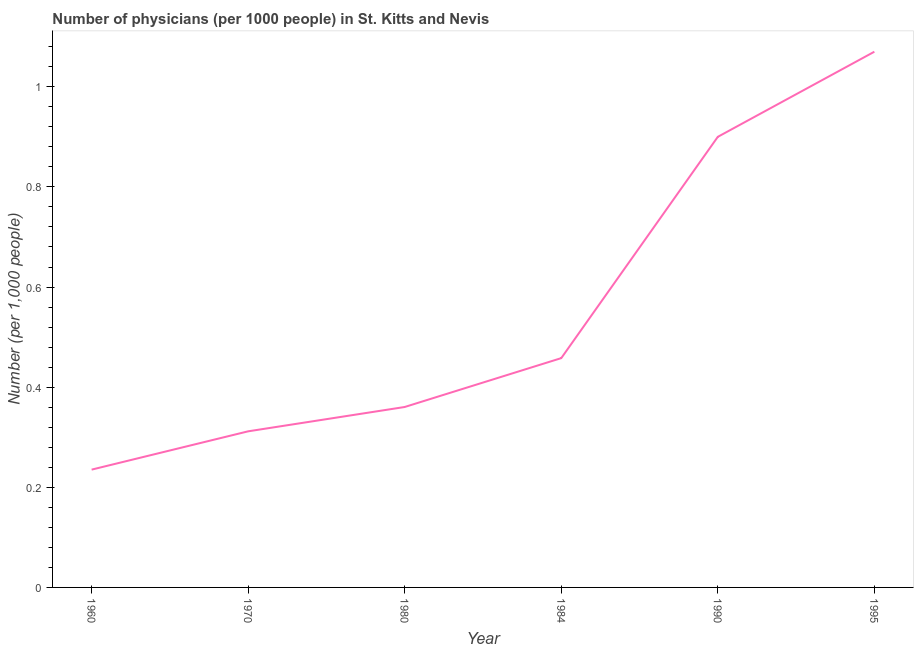What is the number of physicians in 1970?
Offer a terse response. 0.31. Across all years, what is the maximum number of physicians?
Provide a succinct answer. 1.07. Across all years, what is the minimum number of physicians?
Give a very brief answer. 0.24. In which year was the number of physicians maximum?
Your response must be concise. 1995. What is the sum of the number of physicians?
Your response must be concise. 3.34. What is the difference between the number of physicians in 1980 and 1995?
Your answer should be very brief. -0.71. What is the average number of physicians per year?
Provide a short and direct response. 0.56. What is the median number of physicians?
Provide a short and direct response. 0.41. What is the ratio of the number of physicians in 1980 to that in 1990?
Offer a very short reply. 0.4. What is the difference between the highest and the second highest number of physicians?
Keep it short and to the point. 0.17. Is the sum of the number of physicians in 1980 and 1995 greater than the maximum number of physicians across all years?
Keep it short and to the point. Yes. What is the difference between the highest and the lowest number of physicians?
Keep it short and to the point. 0.83. How many years are there in the graph?
Ensure brevity in your answer.  6. Are the values on the major ticks of Y-axis written in scientific E-notation?
Keep it short and to the point. No. Does the graph contain grids?
Provide a succinct answer. No. What is the title of the graph?
Your response must be concise. Number of physicians (per 1000 people) in St. Kitts and Nevis. What is the label or title of the X-axis?
Your answer should be very brief. Year. What is the label or title of the Y-axis?
Provide a succinct answer. Number (per 1,0 people). What is the Number (per 1,000 people) in 1960?
Offer a very short reply. 0.24. What is the Number (per 1,000 people) of 1970?
Your response must be concise. 0.31. What is the Number (per 1,000 people) of 1980?
Provide a short and direct response. 0.36. What is the Number (per 1,000 people) in 1984?
Keep it short and to the point. 0.46. What is the Number (per 1,000 people) of 1990?
Your answer should be very brief. 0.9. What is the Number (per 1,000 people) of 1995?
Make the answer very short. 1.07. What is the difference between the Number (per 1,000 people) in 1960 and 1970?
Your answer should be compact. -0.08. What is the difference between the Number (per 1,000 people) in 1960 and 1980?
Offer a terse response. -0.13. What is the difference between the Number (per 1,000 people) in 1960 and 1984?
Ensure brevity in your answer.  -0.22. What is the difference between the Number (per 1,000 people) in 1960 and 1990?
Your answer should be compact. -0.66. What is the difference between the Number (per 1,000 people) in 1960 and 1995?
Keep it short and to the point. -0.83. What is the difference between the Number (per 1,000 people) in 1970 and 1980?
Make the answer very short. -0.05. What is the difference between the Number (per 1,000 people) in 1970 and 1984?
Give a very brief answer. -0.15. What is the difference between the Number (per 1,000 people) in 1970 and 1990?
Offer a terse response. -0.59. What is the difference between the Number (per 1,000 people) in 1970 and 1995?
Offer a terse response. -0.76. What is the difference between the Number (per 1,000 people) in 1980 and 1984?
Offer a terse response. -0.1. What is the difference between the Number (per 1,000 people) in 1980 and 1990?
Your response must be concise. -0.54. What is the difference between the Number (per 1,000 people) in 1980 and 1995?
Offer a terse response. -0.71. What is the difference between the Number (per 1,000 people) in 1984 and 1990?
Ensure brevity in your answer.  -0.44. What is the difference between the Number (per 1,000 people) in 1984 and 1995?
Ensure brevity in your answer.  -0.61. What is the difference between the Number (per 1,000 people) in 1990 and 1995?
Give a very brief answer. -0.17. What is the ratio of the Number (per 1,000 people) in 1960 to that in 1970?
Offer a very short reply. 0.76. What is the ratio of the Number (per 1,000 people) in 1960 to that in 1980?
Your answer should be very brief. 0.65. What is the ratio of the Number (per 1,000 people) in 1960 to that in 1984?
Keep it short and to the point. 0.51. What is the ratio of the Number (per 1,000 people) in 1960 to that in 1990?
Offer a very short reply. 0.26. What is the ratio of the Number (per 1,000 people) in 1960 to that in 1995?
Give a very brief answer. 0.22. What is the ratio of the Number (per 1,000 people) in 1970 to that in 1980?
Give a very brief answer. 0.86. What is the ratio of the Number (per 1,000 people) in 1970 to that in 1984?
Provide a short and direct response. 0.68. What is the ratio of the Number (per 1,000 people) in 1970 to that in 1990?
Your answer should be very brief. 0.35. What is the ratio of the Number (per 1,000 people) in 1970 to that in 1995?
Your answer should be compact. 0.29. What is the ratio of the Number (per 1,000 people) in 1980 to that in 1984?
Make the answer very short. 0.79. What is the ratio of the Number (per 1,000 people) in 1980 to that in 1990?
Ensure brevity in your answer.  0.4. What is the ratio of the Number (per 1,000 people) in 1980 to that in 1995?
Your answer should be very brief. 0.34. What is the ratio of the Number (per 1,000 people) in 1984 to that in 1990?
Provide a succinct answer. 0.51. What is the ratio of the Number (per 1,000 people) in 1984 to that in 1995?
Your answer should be very brief. 0.43. What is the ratio of the Number (per 1,000 people) in 1990 to that in 1995?
Provide a short and direct response. 0.84. 